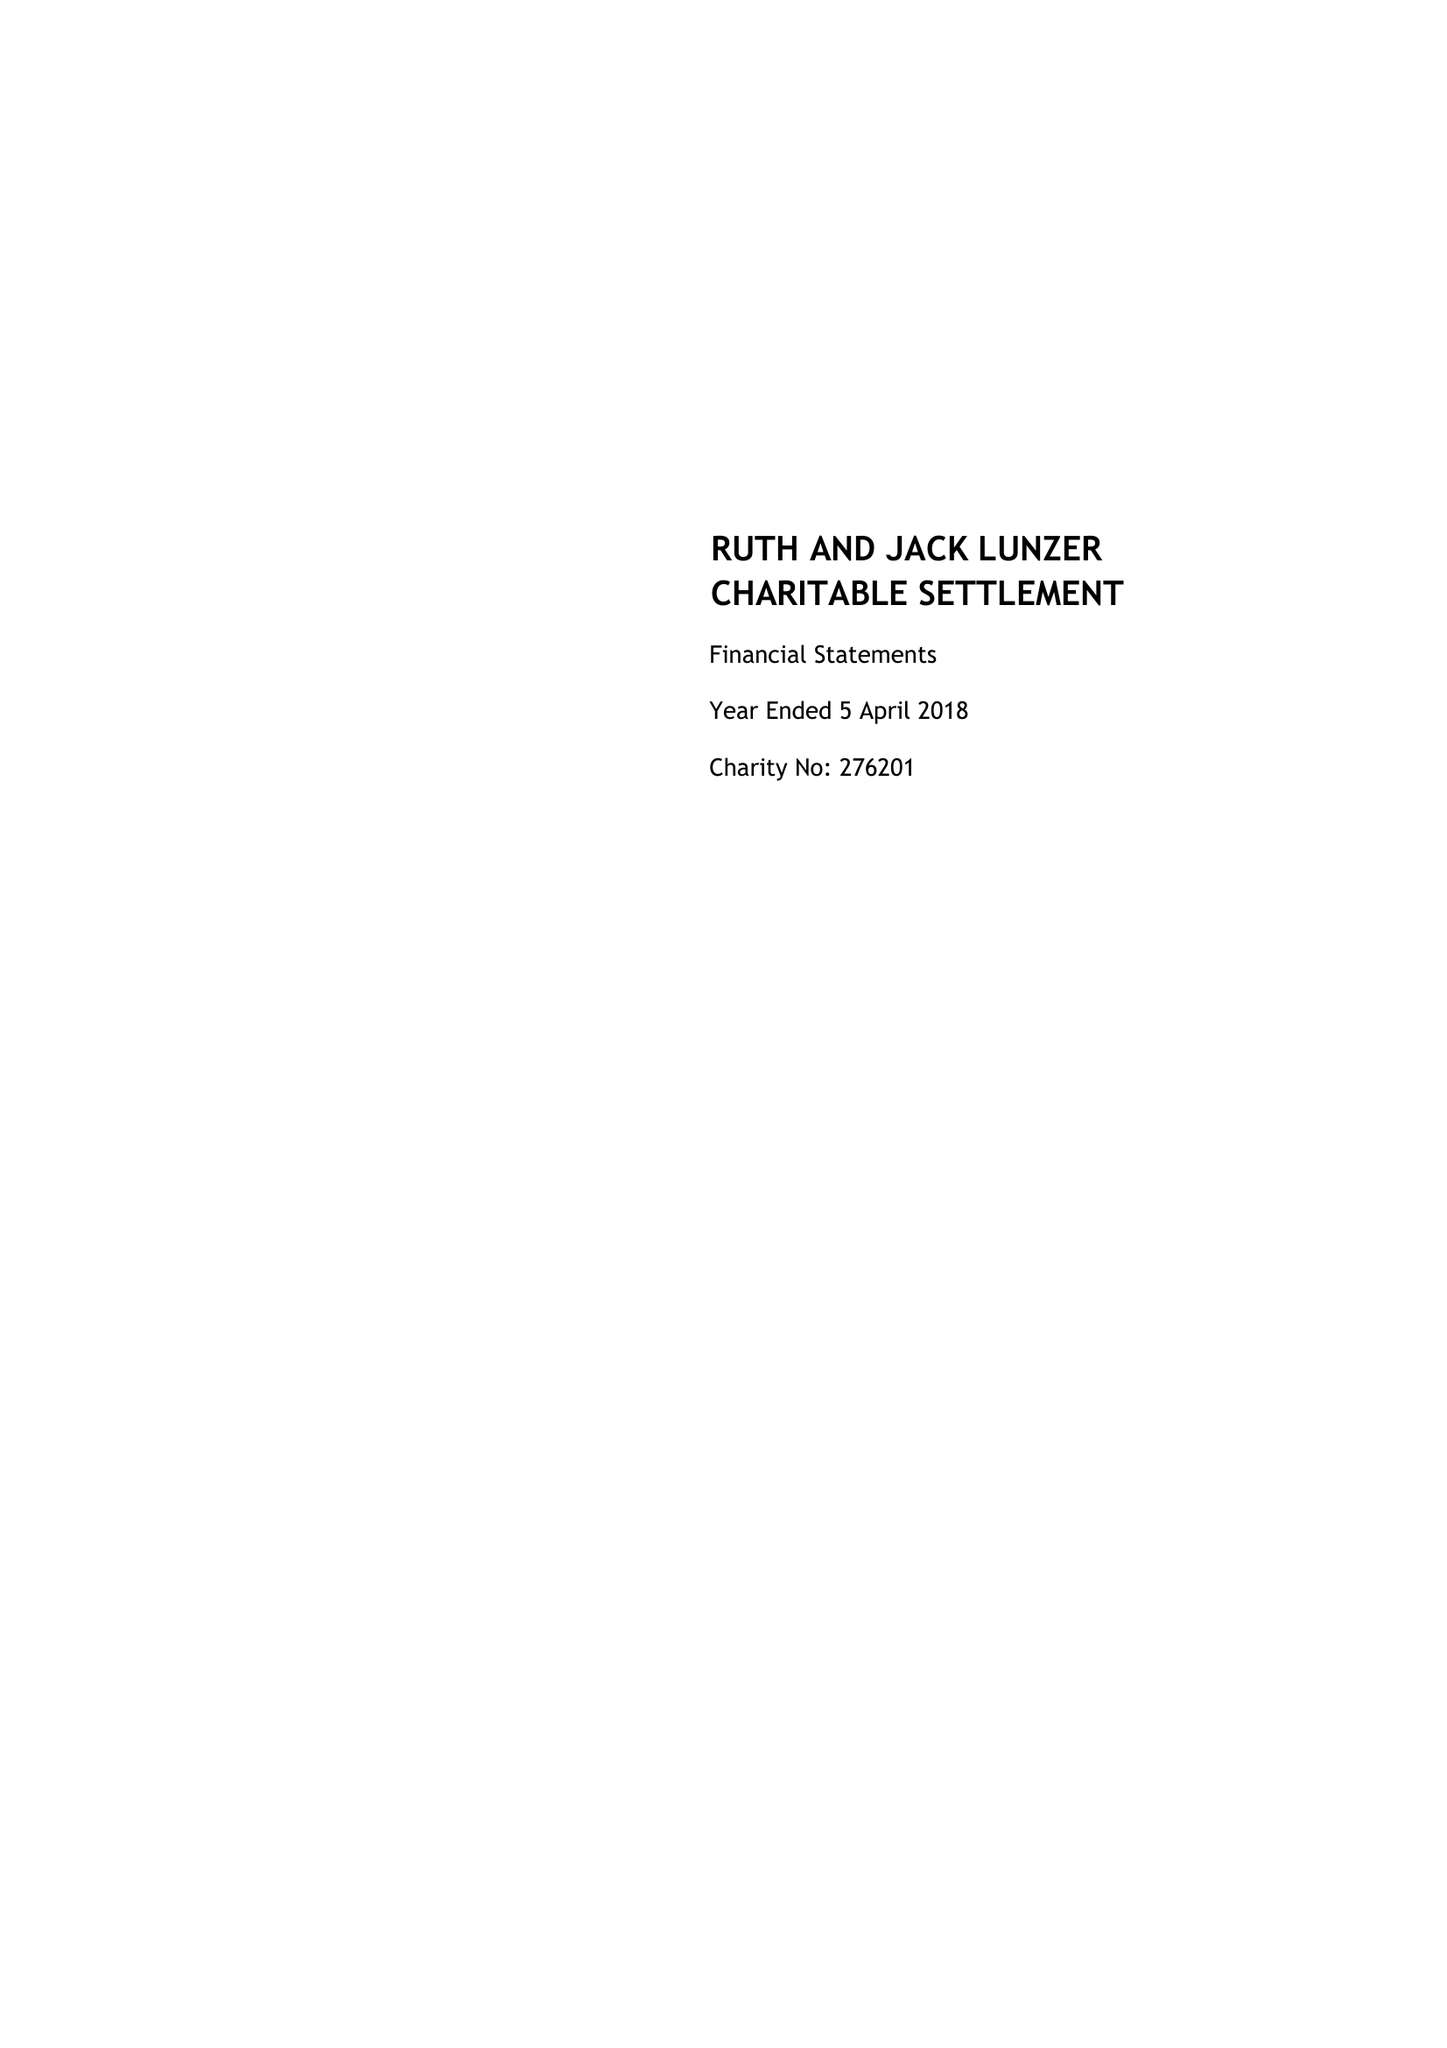What is the value for the address__postcode?
Answer the question using a single word or phrase. EC4R 9HA 